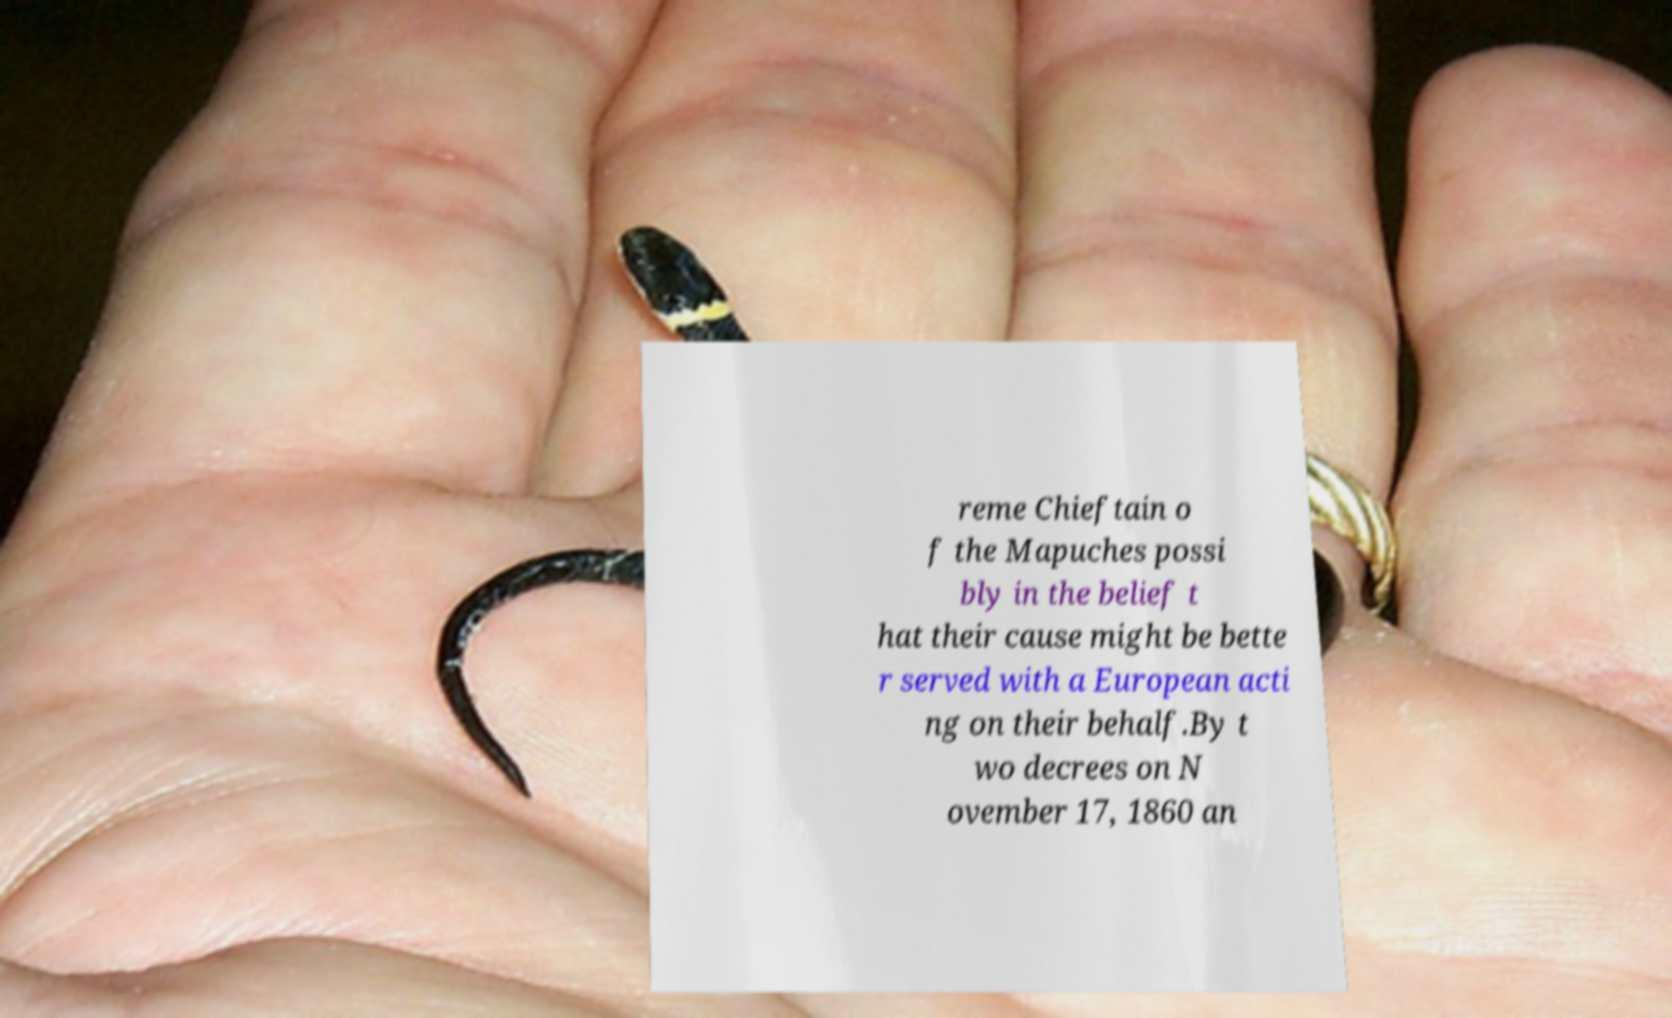Please read and relay the text visible in this image. What does it say? reme Chieftain o f the Mapuches possi bly in the belief t hat their cause might be bette r served with a European acti ng on their behalf.By t wo decrees on N ovember 17, 1860 an 